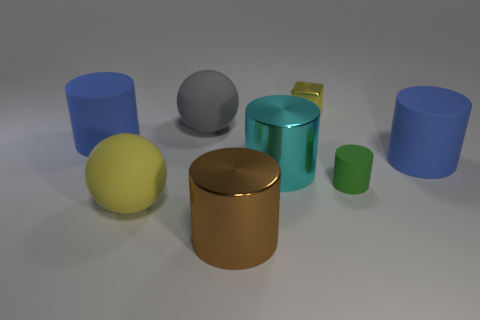The tiny object that is the same shape as the large cyan metal object is what color?
Keep it short and to the point. Green. Are there more small green matte cylinders that are on the left side of the small green object than cylinders?
Provide a short and direct response. No. There is a large rubber sphere on the left side of the big gray rubber thing; what is its color?
Provide a short and direct response. Yellow. Does the green rubber cylinder have the same size as the gray sphere?
Provide a succinct answer. No. The yellow matte object is what size?
Your answer should be very brief. Large. There is a large object that is the same color as the metal block; what shape is it?
Provide a succinct answer. Sphere. Are there more spheres than large matte things?
Ensure brevity in your answer.  No. There is a rubber cylinder on the left side of the metallic thing that is in front of the small green thing right of the big brown metallic object; what is its color?
Your answer should be very brief. Blue. Do the big blue rubber object left of the big gray object and the big cyan shiny thing have the same shape?
Provide a succinct answer. Yes. There is a block that is the same size as the green cylinder; what is its color?
Provide a succinct answer. Yellow. 